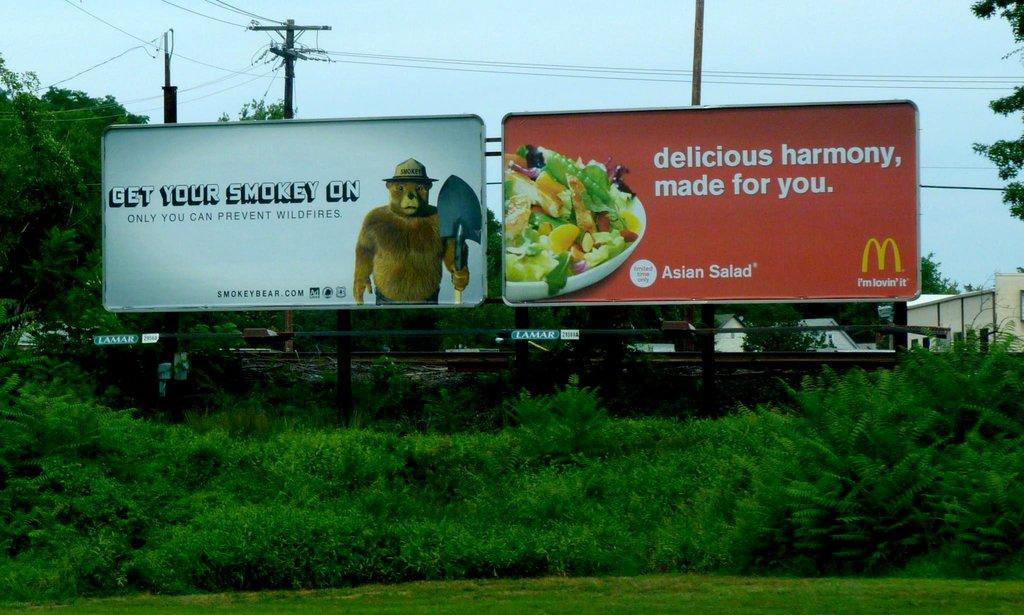<image>
Write a terse but informative summary of the picture. A billboard with Smokey the Bear is next to a Mcdonalds billboard highlighting their Asian Salad. 